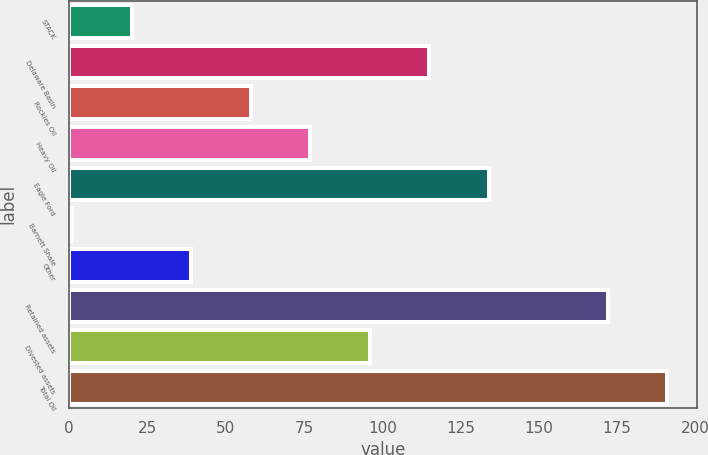Convert chart to OTSL. <chart><loc_0><loc_0><loc_500><loc_500><bar_chart><fcel>STACK<fcel>Delaware Basin<fcel>Rockies Oil<fcel>Heavy Oil<fcel>Eagle Ford<fcel>Barnett Shale<fcel>Other<fcel>Retained assets<fcel>Divested assets<fcel>Total Oil<nl><fcel>20<fcel>115<fcel>58<fcel>77<fcel>134<fcel>1<fcel>39<fcel>172<fcel>96<fcel>191<nl></chart> 